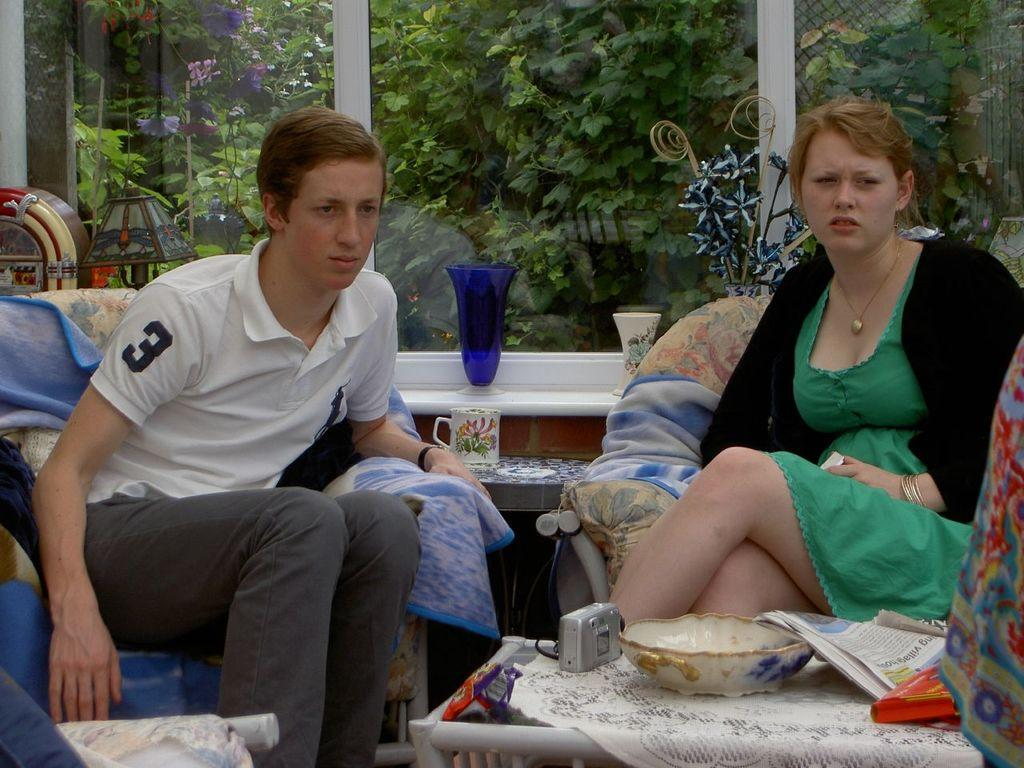What are the people in the image doing? The people in the image are sitting in chairs. What is in front of the chairs? There is a table in front of the chairs. What can be found on the table? There are objects on the table. What can be seen in the background of the image? There is a glass window and potted plants in the background. What type of flesh can be seen on the table in the image? There is no flesh present on the table in the image. Who is the father of the person sitting in the chair on the left? The provided facts do not mention any family relationships, so it is impossible to determine the father of the person sitting in the chair on the left. 